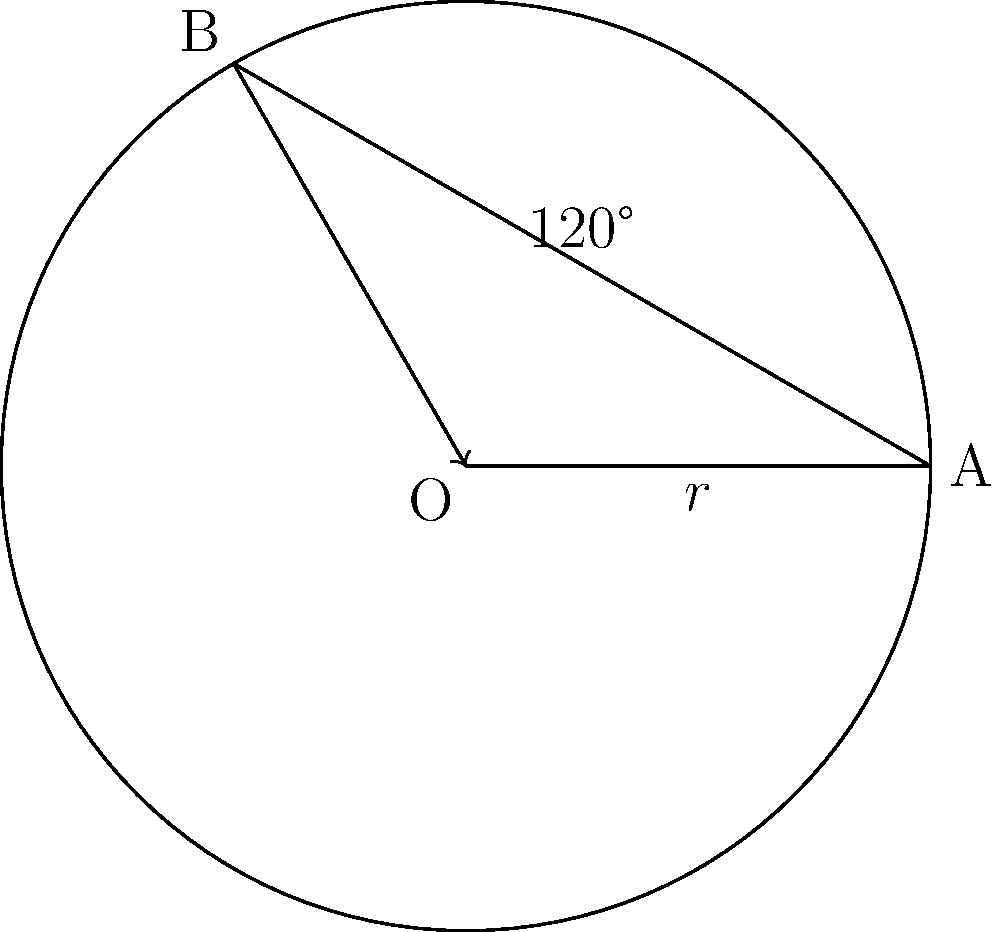During a stage of the Tour de France, a Team Slipstream cyclist's bike has wheels with a radius of 35 cm. If the wheel makes 1000 complete rotations, how far has the cyclist traveled? Express your answer in kilometers, rounded to two decimal places. Let's approach this step-by-step:

1) First, we need to calculate the circumference of the wheel. The formula for circumference is:

   $C = 2\pi r$

   where $r$ is the radius of the wheel.

2) Plugging in our value:

   $C = 2\pi(35\text{ cm}) = 70\pi\text{ cm}$

3) Now, for each complete rotation, the bike travels one circumference. So for 1000 rotations, the distance traveled is:

   $D = 1000 \cdot 70\pi\text{ cm} = 70000\pi\text{ cm}$

4) Let's convert this to kilometers:

   $70000\pi\text{ cm} = 700\pi\text{ m} = \frac{700\pi}{1000}\text{ km}$

5) Calculating this:

   $\frac{700\pi}{1000} \approx 2.1991\text{ km}$

6) Rounding to two decimal places:

   $2.20\text{ km}$
Answer: 2.20 km 